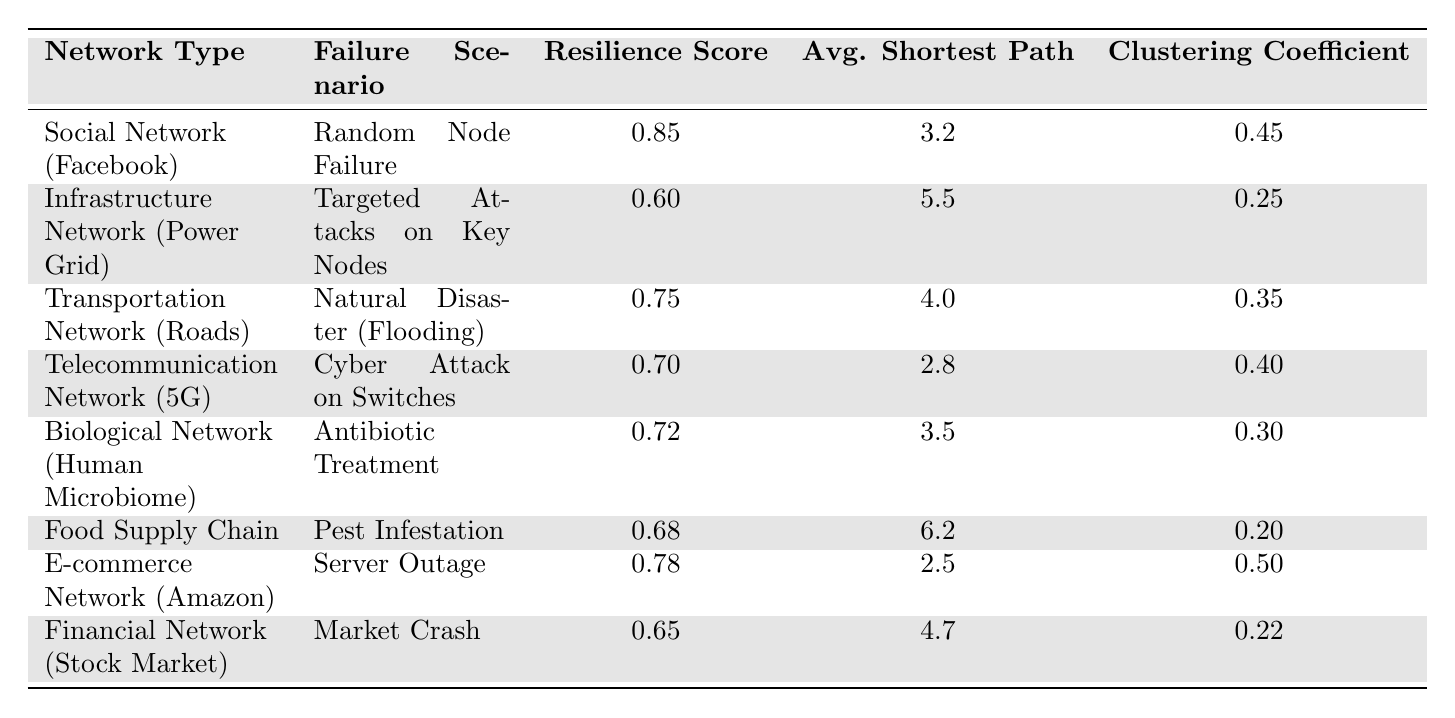What is the resilience score for the Social Network (Facebook)? From the table, we can directly see that the resilience score for the Social Network (Facebook) listed under the corresponding network type is 0.85.
Answer: 0.85 Which network type has the lowest resilience score? Looking across all the resilience scores in the table, the Infrastructure Network (Power Grid) has the lowest score, which is 0.60.
Answer: Infrastructure Network (Power Grid) What is the average shortest path length for the E-commerce Network (Amazon)? The table shows that the average shortest path length for the E-commerce Network (Amazon) is 2.5.
Answer: 2.5 Is the clustering coefficient higher for the Transportation Network (Roads) than for the Telecommunication Network (5G)? The clustering coefficient for the Transportation Network (Roads) is 0.35, while for the Telecommunication Network (5G) it is 0.40. Since 0.35 is less than 0.40, the statement is false.
Answer: No What is the average resilience score of all network types listed in the table? To find the average resilience score, we sum the resilience scores of all networks: 0.85 + 0.60 + 0.75 + 0.70 + 0.72 + 0.68 + 0.78 + 0.65 = 5.03. Then, we divide by the number of networks, which is 8: 5.03 / 8 = 0.62875, rounded to two decimal places equals 0.63.
Answer: 0.63 Which failure scenario corresponds to a resilience score higher than 0.7? By checking the resilience scores, we see that the following scenarios have scores above 0.7: Random Node Failure (0.85), Natural Disaster (Flooding) (0.75), Cyber Attack on Switches (0.70), Antibiotic Treatment (0.72), and Server Outage (0.78).
Answer: Multiple scenarios What is the difference in average shortest path length between the Food Supply Chain and the Infrastructure Network (Power Grid)? From the table, the average shortest path length for the Food Supply Chain is 6.2, and for the Infrastructure Network (Power Grid) it is 5.5. The difference is calculated as 6.2 - 5.5 = 0.7.
Answer: 0.7 Which network type exhibits the highest clustering coefficient and what is that value? Scanning the clustering coefficients in the table, the E-commerce Network (Amazon) has the highest clustering coefficient at 0.50.
Answer: E-commerce Network (Amazon), 0.50 How does the resilience score for Biological Network (Human Microbiome) compare to that of the Financial Network (Stock Market)? The resilience score of the Biological Network (Human Microbiome) is 0.72, whereas the Financial Network (Stock Market) has a score of 0.65. Since 0.72 is greater than 0.65, we conclude that the Biological Network (Human Microbiome) has a higher resilience score.
Answer: Higher What is the total clustering coefficient across all networks listed? To find the total clustering coefficient, we add all the individual clustering coefficients: 0.45 + 0.25 + 0.35 + 0.40 + 0.30 + 0.20 + 0.50 + 0.22 = 2.67.
Answer: 2.67 